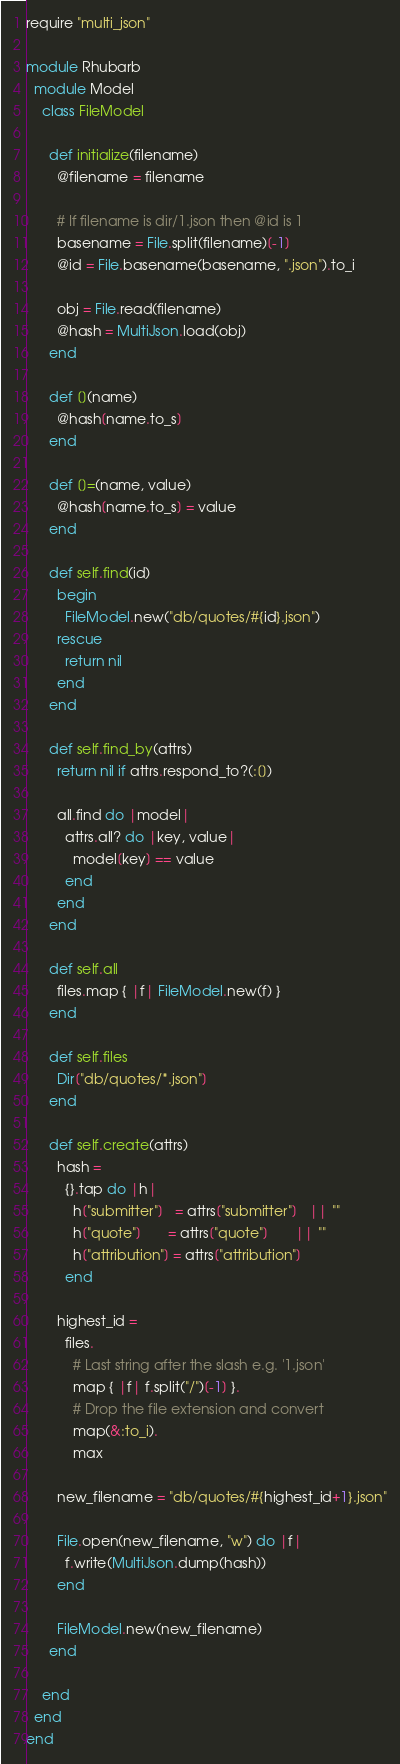<code> <loc_0><loc_0><loc_500><loc_500><_Ruby_>require "multi_json"

module Rhubarb
  module Model
    class FileModel

      def initialize(filename)
        @filename = filename

        # If filename is dir/1.json then @id is 1
        basename = File.split(filename)[-1]
        @id = File.basename(basename, ".json").to_i

        obj = File.read(filename)
        @hash = MultiJson.load(obj)
      end

      def [](name)
        @hash[name.to_s]
      end

      def []=(name, value)
        @hash[name.to_s] = value
      end

      def self.find(id)
        begin
          FileModel.new("db/quotes/#{id}.json")
        rescue
          return nil
        end
      end

      def self.find_by(attrs)
        return nil if attrs.respond_to?(:[])

        all.find do |model|
          attrs.all? do |key, value|
            model[key] == value
          end
        end
      end

      def self.all
        files.map { |f| FileModel.new(f) }
      end

      def self.files
        Dir["db/quotes/*.json"]
      end

      def self.create(attrs)
        hash =
          {}.tap do |h|
            h["submitter"]   = attrs["submitter"]   || ""
            h["quote"]       = attrs["quote"]       || ""
            h["attribution"] = attrs["attribution"]
          end

        highest_id =
          files.
            # Last string after the slash e.g. '1.json'
            map { |f| f.split("/")[-1] }.
            # Drop the file extension and convert
            map(&:to_i).
            max

        new_filename = "db/quotes/#{highest_id+1}.json"

        File.open(new_filename, "w") do |f|
          f.write(MultiJson.dump(hash))
        end

        FileModel.new(new_filename)
      end

    end
  end
end
</code> 